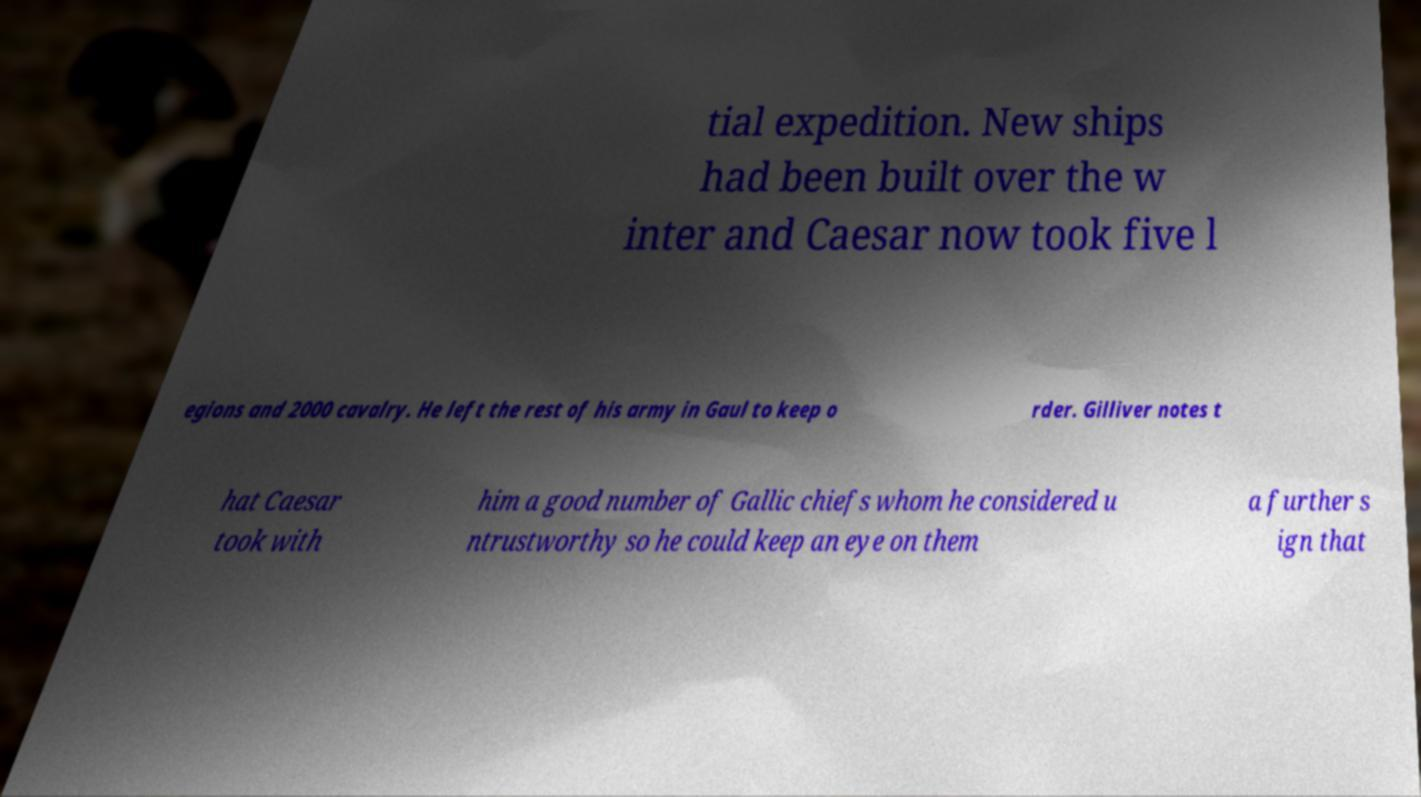Can you read and provide the text displayed in the image?This photo seems to have some interesting text. Can you extract and type it out for me? tial expedition. New ships had been built over the w inter and Caesar now took five l egions and 2000 cavalry. He left the rest of his army in Gaul to keep o rder. Gilliver notes t hat Caesar took with him a good number of Gallic chiefs whom he considered u ntrustworthy so he could keep an eye on them a further s ign that 